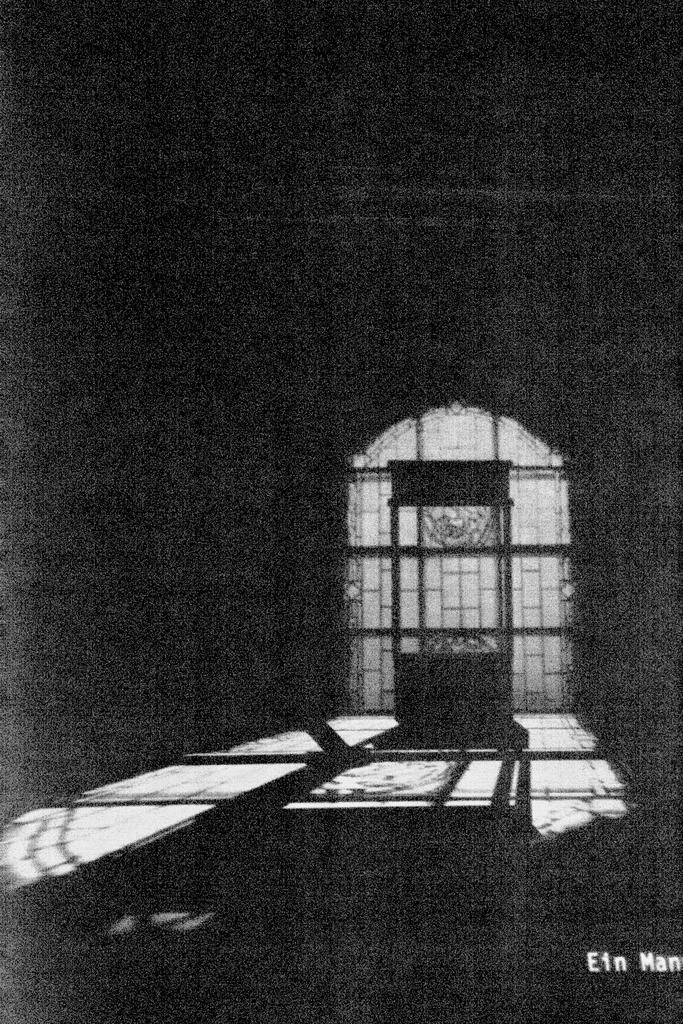What is the color scheme of the image? The image is black and white. What structure can be seen in the image? There is a gate in the image. What type of object is present in the image? There are grills in the image. How would you describe the lighting at the top of the image? The top of the image is dark. Can you see any corn growing near the gate in the image? There is no corn visible in the image. What type of ocean can be seen in the background of the image? There is no ocean present in the image; it is a black and white image featuring a gate and grills. 